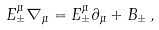<formula> <loc_0><loc_0><loc_500><loc_500>E ^ { \mu } _ { \pm } \nabla _ { \mu } = E ^ { \mu } _ { \pm } \partial _ { \mu } + B _ { \pm } \, ,</formula> 